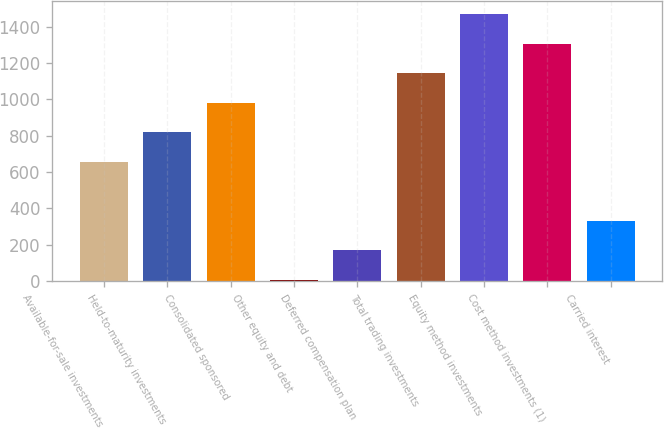<chart> <loc_0><loc_0><loc_500><loc_500><bar_chart><fcel>Available-for-sale investments<fcel>Held-to-maturity investments<fcel>Consolidated sponsored<fcel>Other equity and debt<fcel>Deferred compensation plan<fcel>Total trading investments<fcel>Equity method investments<fcel>Cost method investments (1)<fcel>Carried interest<nl><fcel>656.6<fcel>819<fcel>981.4<fcel>7<fcel>169.4<fcel>1143.8<fcel>1468.6<fcel>1306.2<fcel>331.8<nl></chart> 